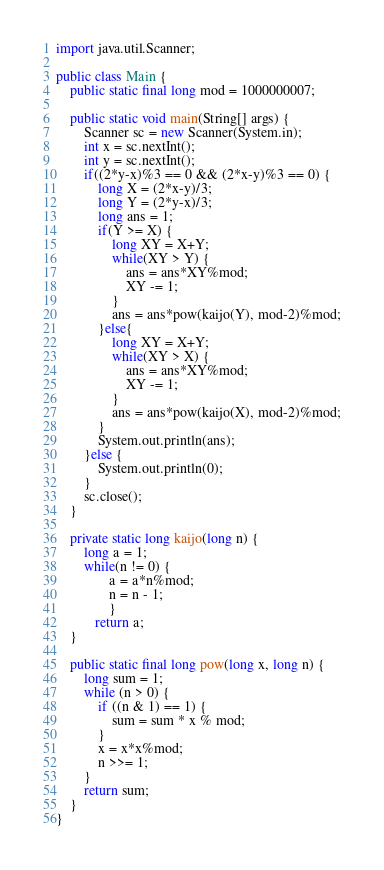<code> <loc_0><loc_0><loc_500><loc_500><_Java_>import java.util.Scanner;

public class Main {
	public static final long mod = 1000000007;

	public static void main(String[] args) {
		Scanner sc = new Scanner(System.in);
		int x = sc.nextInt();
		int y = sc.nextInt();
		if((2*y-x)%3 == 0 && (2*x-y)%3 == 0) {
			long X = (2*x-y)/3;
			long Y = (2*y-x)/3;
			long ans = 1;
			if(Y >= X) {
				long XY = X+Y;
				while(XY > Y) {
					ans = ans*XY%mod;
					XY -= 1;
				}
				ans = ans*pow(kaijo(Y), mod-2)%mod;
			}else{
				long XY = X+Y;
				while(XY > X) {
					ans = ans*XY%mod;
					XY -= 1;
				}
				ans = ans*pow(kaijo(X), mod-2)%mod;
			}
			System.out.println(ans);
		}else {
			System.out.println(0);
		}
		sc.close();
	}

	private static long kaijo(long n) {
	    long a = 1;
		while(n != 0) {
	           a = a*n%mod;
	           n = n - 1;
	           }
	       return a;
	}

	public static final long pow(long x, long n) {
	    long sum = 1;
	    while (n > 0) {
	        if ((n & 1) == 1) {
	            sum = sum * x % mod;
	        }
	        x = x*x%mod;
	        n >>= 1;
	    }
	    return sum;
	}
}</code> 